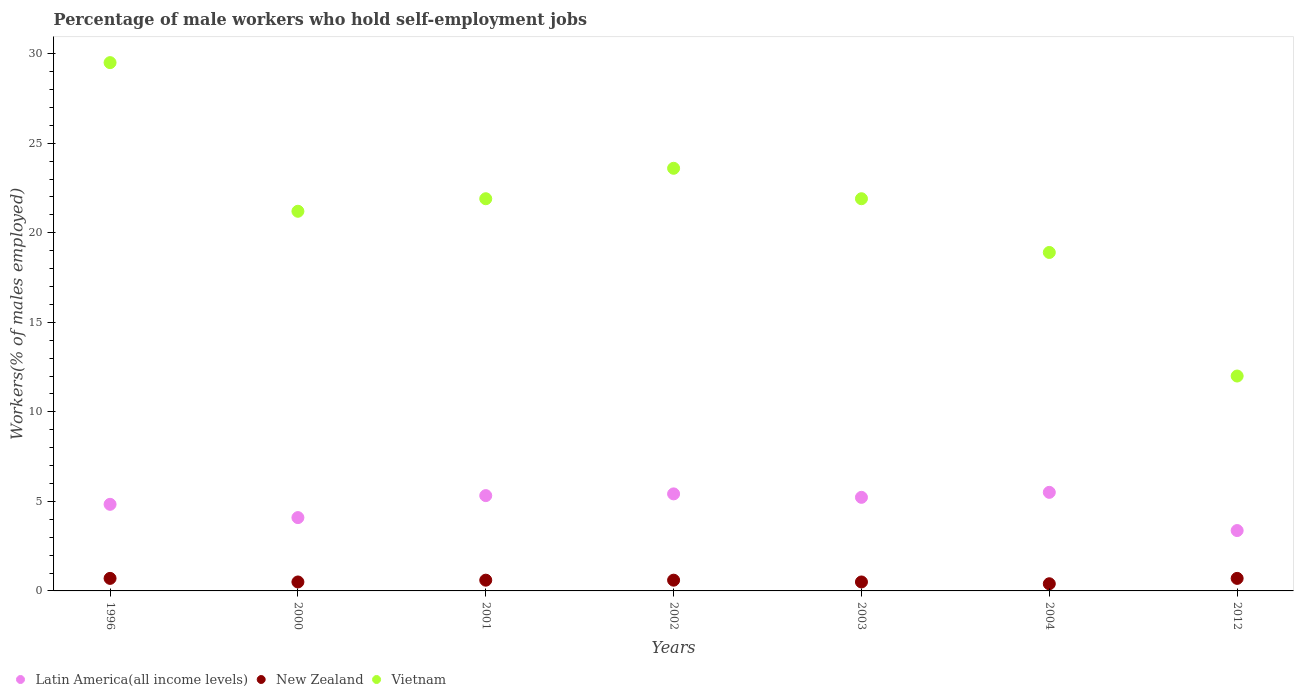How many different coloured dotlines are there?
Offer a terse response. 3. Is the number of dotlines equal to the number of legend labels?
Make the answer very short. Yes. What is the percentage of self-employed male workers in New Zealand in 2004?
Offer a very short reply. 0.4. Across all years, what is the maximum percentage of self-employed male workers in Latin America(all income levels)?
Offer a terse response. 5.5. Across all years, what is the minimum percentage of self-employed male workers in Vietnam?
Give a very brief answer. 12. In which year was the percentage of self-employed male workers in Latin America(all income levels) maximum?
Make the answer very short. 2004. In which year was the percentage of self-employed male workers in Latin America(all income levels) minimum?
Offer a terse response. 2012. What is the total percentage of self-employed male workers in New Zealand in the graph?
Your answer should be very brief. 4. What is the difference between the percentage of self-employed male workers in New Zealand in 2001 and that in 2003?
Your answer should be very brief. 0.1. What is the difference between the percentage of self-employed male workers in Latin America(all income levels) in 2002 and the percentage of self-employed male workers in Vietnam in 1996?
Offer a very short reply. -24.08. What is the average percentage of self-employed male workers in Vietnam per year?
Provide a succinct answer. 21.29. In the year 2003, what is the difference between the percentage of self-employed male workers in New Zealand and percentage of self-employed male workers in Vietnam?
Make the answer very short. -21.4. What is the ratio of the percentage of self-employed male workers in New Zealand in 2001 to that in 2003?
Provide a short and direct response. 1.2. Is the percentage of self-employed male workers in Vietnam in 2000 less than that in 2012?
Make the answer very short. No. Is the difference between the percentage of self-employed male workers in New Zealand in 2000 and 2003 greater than the difference between the percentage of self-employed male workers in Vietnam in 2000 and 2003?
Your answer should be very brief. Yes. What is the difference between the highest and the second highest percentage of self-employed male workers in Vietnam?
Make the answer very short. 5.9. What is the difference between the highest and the lowest percentage of self-employed male workers in Latin America(all income levels)?
Provide a succinct answer. 2.13. Is the sum of the percentage of self-employed male workers in New Zealand in 2002 and 2012 greater than the maximum percentage of self-employed male workers in Vietnam across all years?
Your answer should be very brief. No. Is it the case that in every year, the sum of the percentage of self-employed male workers in Latin America(all income levels) and percentage of self-employed male workers in New Zealand  is greater than the percentage of self-employed male workers in Vietnam?
Ensure brevity in your answer.  No. Is the percentage of self-employed male workers in Vietnam strictly less than the percentage of self-employed male workers in New Zealand over the years?
Give a very brief answer. No. How many dotlines are there?
Your answer should be compact. 3. How many years are there in the graph?
Your answer should be compact. 7. What is the difference between two consecutive major ticks on the Y-axis?
Offer a terse response. 5. Does the graph contain any zero values?
Offer a very short reply. No. Does the graph contain grids?
Provide a succinct answer. No. How many legend labels are there?
Offer a terse response. 3. How are the legend labels stacked?
Your response must be concise. Horizontal. What is the title of the graph?
Keep it short and to the point. Percentage of male workers who hold self-employment jobs. What is the label or title of the Y-axis?
Offer a very short reply. Workers(% of males employed). What is the Workers(% of males employed) of Latin America(all income levels) in 1996?
Keep it short and to the point. 4.84. What is the Workers(% of males employed) of New Zealand in 1996?
Keep it short and to the point. 0.7. What is the Workers(% of males employed) in Vietnam in 1996?
Offer a terse response. 29.5. What is the Workers(% of males employed) of Latin America(all income levels) in 2000?
Keep it short and to the point. 4.09. What is the Workers(% of males employed) of Vietnam in 2000?
Your response must be concise. 21.2. What is the Workers(% of males employed) of Latin America(all income levels) in 2001?
Make the answer very short. 5.32. What is the Workers(% of males employed) in New Zealand in 2001?
Give a very brief answer. 0.6. What is the Workers(% of males employed) of Vietnam in 2001?
Keep it short and to the point. 21.9. What is the Workers(% of males employed) of Latin America(all income levels) in 2002?
Your answer should be compact. 5.42. What is the Workers(% of males employed) of New Zealand in 2002?
Make the answer very short. 0.6. What is the Workers(% of males employed) in Vietnam in 2002?
Ensure brevity in your answer.  23.6. What is the Workers(% of males employed) in Latin America(all income levels) in 2003?
Your answer should be very brief. 5.23. What is the Workers(% of males employed) of New Zealand in 2003?
Your response must be concise. 0.5. What is the Workers(% of males employed) of Vietnam in 2003?
Offer a terse response. 21.9. What is the Workers(% of males employed) of Latin America(all income levels) in 2004?
Ensure brevity in your answer.  5.5. What is the Workers(% of males employed) in New Zealand in 2004?
Your response must be concise. 0.4. What is the Workers(% of males employed) in Vietnam in 2004?
Make the answer very short. 18.9. What is the Workers(% of males employed) in Latin America(all income levels) in 2012?
Provide a short and direct response. 3.37. What is the Workers(% of males employed) of New Zealand in 2012?
Provide a short and direct response. 0.7. Across all years, what is the maximum Workers(% of males employed) in Latin America(all income levels)?
Offer a very short reply. 5.5. Across all years, what is the maximum Workers(% of males employed) in New Zealand?
Keep it short and to the point. 0.7. Across all years, what is the maximum Workers(% of males employed) of Vietnam?
Your answer should be very brief. 29.5. Across all years, what is the minimum Workers(% of males employed) in Latin America(all income levels)?
Offer a terse response. 3.37. Across all years, what is the minimum Workers(% of males employed) in New Zealand?
Ensure brevity in your answer.  0.4. Across all years, what is the minimum Workers(% of males employed) in Vietnam?
Give a very brief answer. 12. What is the total Workers(% of males employed) in Latin America(all income levels) in the graph?
Provide a short and direct response. 33.77. What is the total Workers(% of males employed) of Vietnam in the graph?
Your answer should be very brief. 149. What is the difference between the Workers(% of males employed) of Latin America(all income levels) in 1996 and that in 2000?
Offer a terse response. 0.74. What is the difference between the Workers(% of males employed) of New Zealand in 1996 and that in 2000?
Ensure brevity in your answer.  0.2. What is the difference between the Workers(% of males employed) of Latin America(all income levels) in 1996 and that in 2001?
Your answer should be compact. -0.49. What is the difference between the Workers(% of males employed) of Vietnam in 1996 and that in 2001?
Offer a terse response. 7.6. What is the difference between the Workers(% of males employed) in Latin America(all income levels) in 1996 and that in 2002?
Your response must be concise. -0.58. What is the difference between the Workers(% of males employed) of New Zealand in 1996 and that in 2002?
Make the answer very short. 0.1. What is the difference between the Workers(% of males employed) of Vietnam in 1996 and that in 2002?
Give a very brief answer. 5.9. What is the difference between the Workers(% of males employed) of Latin America(all income levels) in 1996 and that in 2003?
Provide a short and direct response. -0.39. What is the difference between the Workers(% of males employed) in New Zealand in 1996 and that in 2003?
Your answer should be very brief. 0.2. What is the difference between the Workers(% of males employed) of Vietnam in 1996 and that in 2003?
Your answer should be very brief. 7.6. What is the difference between the Workers(% of males employed) of Latin America(all income levels) in 1996 and that in 2004?
Your answer should be compact. -0.67. What is the difference between the Workers(% of males employed) of New Zealand in 1996 and that in 2004?
Keep it short and to the point. 0.3. What is the difference between the Workers(% of males employed) in Latin America(all income levels) in 1996 and that in 2012?
Provide a succinct answer. 1.46. What is the difference between the Workers(% of males employed) of New Zealand in 1996 and that in 2012?
Make the answer very short. 0. What is the difference between the Workers(% of males employed) in Vietnam in 1996 and that in 2012?
Give a very brief answer. 17.5. What is the difference between the Workers(% of males employed) in Latin America(all income levels) in 2000 and that in 2001?
Make the answer very short. -1.23. What is the difference between the Workers(% of males employed) in New Zealand in 2000 and that in 2001?
Provide a short and direct response. -0.1. What is the difference between the Workers(% of males employed) in Latin America(all income levels) in 2000 and that in 2002?
Offer a very short reply. -1.32. What is the difference between the Workers(% of males employed) of New Zealand in 2000 and that in 2002?
Provide a short and direct response. -0.1. What is the difference between the Workers(% of males employed) in Vietnam in 2000 and that in 2002?
Offer a very short reply. -2.4. What is the difference between the Workers(% of males employed) in Latin America(all income levels) in 2000 and that in 2003?
Offer a terse response. -1.13. What is the difference between the Workers(% of males employed) of New Zealand in 2000 and that in 2003?
Keep it short and to the point. 0. What is the difference between the Workers(% of males employed) of Latin America(all income levels) in 2000 and that in 2004?
Provide a short and direct response. -1.41. What is the difference between the Workers(% of males employed) of New Zealand in 2000 and that in 2004?
Keep it short and to the point. 0.1. What is the difference between the Workers(% of males employed) in Vietnam in 2000 and that in 2004?
Provide a short and direct response. 2.3. What is the difference between the Workers(% of males employed) of Latin America(all income levels) in 2000 and that in 2012?
Ensure brevity in your answer.  0.72. What is the difference between the Workers(% of males employed) in Latin America(all income levels) in 2001 and that in 2002?
Your response must be concise. -0.1. What is the difference between the Workers(% of males employed) of New Zealand in 2001 and that in 2002?
Your response must be concise. 0. What is the difference between the Workers(% of males employed) of Vietnam in 2001 and that in 2002?
Keep it short and to the point. -1.7. What is the difference between the Workers(% of males employed) in Latin America(all income levels) in 2001 and that in 2003?
Provide a short and direct response. 0.1. What is the difference between the Workers(% of males employed) in New Zealand in 2001 and that in 2003?
Ensure brevity in your answer.  0.1. What is the difference between the Workers(% of males employed) in Vietnam in 2001 and that in 2003?
Provide a succinct answer. 0. What is the difference between the Workers(% of males employed) of Latin America(all income levels) in 2001 and that in 2004?
Provide a short and direct response. -0.18. What is the difference between the Workers(% of males employed) of Latin America(all income levels) in 2001 and that in 2012?
Offer a very short reply. 1.95. What is the difference between the Workers(% of males employed) of New Zealand in 2001 and that in 2012?
Offer a very short reply. -0.1. What is the difference between the Workers(% of males employed) of Latin America(all income levels) in 2002 and that in 2003?
Offer a very short reply. 0.19. What is the difference between the Workers(% of males employed) in Vietnam in 2002 and that in 2003?
Give a very brief answer. 1.7. What is the difference between the Workers(% of males employed) in Latin America(all income levels) in 2002 and that in 2004?
Your response must be concise. -0.09. What is the difference between the Workers(% of males employed) of Vietnam in 2002 and that in 2004?
Offer a terse response. 4.7. What is the difference between the Workers(% of males employed) of Latin America(all income levels) in 2002 and that in 2012?
Ensure brevity in your answer.  2.05. What is the difference between the Workers(% of males employed) of Vietnam in 2002 and that in 2012?
Offer a very short reply. 11.6. What is the difference between the Workers(% of males employed) of Latin America(all income levels) in 2003 and that in 2004?
Your answer should be very brief. -0.28. What is the difference between the Workers(% of males employed) of New Zealand in 2003 and that in 2004?
Offer a very short reply. 0.1. What is the difference between the Workers(% of males employed) in Vietnam in 2003 and that in 2004?
Ensure brevity in your answer.  3. What is the difference between the Workers(% of males employed) of Latin America(all income levels) in 2003 and that in 2012?
Ensure brevity in your answer.  1.85. What is the difference between the Workers(% of males employed) in Vietnam in 2003 and that in 2012?
Give a very brief answer. 9.9. What is the difference between the Workers(% of males employed) of Latin America(all income levels) in 2004 and that in 2012?
Provide a short and direct response. 2.13. What is the difference between the Workers(% of males employed) in New Zealand in 2004 and that in 2012?
Ensure brevity in your answer.  -0.3. What is the difference between the Workers(% of males employed) in Vietnam in 2004 and that in 2012?
Keep it short and to the point. 6.9. What is the difference between the Workers(% of males employed) in Latin America(all income levels) in 1996 and the Workers(% of males employed) in New Zealand in 2000?
Offer a terse response. 4.34. What is the difference between the Workers(% of males employed) of Latin America(all income levels) in 1996 and the Workers(% of males employed) of Vietnam in 2000?
Keep it short and to the point. -16.36. What is the difference between the Workers(% of males employed) of New Zealand in 1996 and the Workers(% of males employed) of Vietnam in 2000?
Provide a short and direct response. -20.5. What is the difference between the Workers(% of males employed) of Latin America(all income levels) in 1996 and the Workers(% of males employed) of New Zealand in 2001?
Make the answer very short. 4.24. What is the difference between the Workers(% of males employed) in Latin America(all income levels) in 1996 and the Workers(% of males employed) in Vietnam in 2001?
Your answer should be compact. -17.06. What is the difference between the Workers(% of males employed) of New Zealand in 1996 and the Workers(% of males employed) of Vietnam in 2001?
Offer a terse response. -21.2. What is the difference between the Workers(% of males employed) in Latin America(all income levels) in 1996 and the Workers(% of males employed) in New Zealand in 2002?
Give a very brief answer. 4.24. What is the difference between the Workers(% of males employed) in Latin America(all income levels) in 1996 and the Workers(% of males employed) in Vietnam in 2002?
Give a very brief answer. -18.76. What is the difference between the Workers(% of males employed) in New Zealand in 1996 and the Workers(% of males employed) in Vietnam in 2002?
Provide a short and direct response. -22.9. What is the difference between the Workers(% of males employed) of Latin America(all income levels) in 1996 and the Workers(% of males employed) of New Zealand in 2003?
Make the answer very short. 4.34. What is the difference between the Workers(% of males employed) of Latin America(all income levels) in 1996 and the Workers(% of males employed) of Vietnam in 2003?
Your response must be concise. -17.06. What is the difference between the Workers(% of males employed) of New Zealand in 1996 and the Workers(% of males employed) of Vietnam in 2003?
Your answer should be compact. -21.2. What is the difference between the Workers(% of males employed) in Latin America(all income levels) in 1996 and the Workers(% of males employed) in New Zealand in 2004?
Ensure brevity in your answer.  4.44. What is the difference between the Workers(% of males employed) of Latin America(all income levels) in 1996 and the Workers(% of males employed) of Vietnam in 2004?
Make the answer very short. -14.06. What is the difference between the Workers(% of males employed) of New Zealand in 1996 and the Workers(% of males employed) of Vietnam in 2004?
Provide a succinct answer. -18.2. What is the difference between the Workers(% of males employed) of Latin America(all income levels) in 1996 and the Workers(% of males employed) of New Zealand in 2012?
Offer a very short reply. 4.14. What is the difference between the Workers(% of males employed) in Latin America(all income levels) in 1996 and the Workers(% of males employed) in Vietnam in 2012?
Provide a succinct answer. -7.16. What is the difference between the Workers(% of males employed) of Latin America(all income levels) in 2000 and the Workers(% of males employed) of New Zealand in 2001?
Provide a short and direct response. 3.49. What is the difference between the Workers(% of males employed) in Latin America(all income levels) in 2000 and the Workers(% of males employed) in Vietnam in 2001?
Offer a terse response. -17.81. What is the difference between the Workers(% of males employed) of New Zealand in 2000 and the Workers(% of males employed) of Vietnam in 2001?
Provide a succinct answer. -21.4. What is the difference between the Workers(% of males employed) of Latin America(all income levels) in 2000 and the Workers(% of males employed) of New Zealand in 2002?
Provide a short and direct response. 3.49. What is the difference between the Workers(% of males employed) in Latin America(all income levels) in 2000 and the Workers(% of males employed) in Vietnam in 2002?
Offer a terse response. -19.51. What is the difference between the Workers(% of males employed) of New Zealand in 2000 and the Workers(% of males employed) of Vietnam in 2002?
Your answer should be compact. -23.1. What is the difference between the Workers(% of males employed) in Latin America(all income levels) in 2000 and the Workers(% of males employed) in New Zealand in 2003?
Offer a very short reply. 3.59. What is the difference between the Workers(% of males employed) of Latin America(all income levels) in 2000 and the Workers(% of males employed) of Vietnam in 2003?
Offer a terse response. -17.81. What is the difference between the Workers(% of males employed) of New Zealand in 2000 and the Workers(% of males employed) of Vietnam in 2003?
Ensure brevity in your answer.  -21.4. What is the difference between the Workers(% of males employed) in Latin America(all income levels) in 2000 and the Workers(% of males employed) in New Zealand in 2004?
Your answer should be very brief. 3.69. What is the difference between the Workers(% of males employed) of Latin America(all income levels) in 2000 and the Workers(% of males employed) of Vietnam in 2004?
Provide a short and direct response. -14.81. What is the difference between the Workers(% of males employed) in New Zealand in 2000 and the Workers(% of males employed) in Vietnam in 2004?
Make the answer very short. -18.4. What is the difference between the Workers(% of males employed) in Latin America(all income levels) in 2000 and the Workers(% of males employed) in New Zealand in 2012?
Your answer should be very brief. 3.39. What is the difference between the Workers(% of males employed) of Latin America(all income levels) in 2000 and the Workers(% of males employed) of Vietnam in 2012?
Your answer should be compact. -7.91. What is the difference between the Workers(% of males employed) of New Zealand in 2000 and the Workers(% of males employed) of Vietnam in 2012?
Your answer should be compact. -11.5. What is the difference between the Workers(% of males employed) of Latin America(all income levels) in 2001 and the Workers(% of males employed) of New Zealand in 2002?
Make the answer very short. 4.72. What is the difference between the Workers(% of males employed) of Latin America(all income levels) in 2001 and the Workers(% of males employed) of Vietnam in 2002?
Offer a very short reply. -18.28. What is the difference between the Workers(% of males employed) in New Zealand in 2001 and the Workers(% of males employed) in Vietnam in 2002?
Your answer should be compact. -23. What is the difference between the Workers(% of males employed) in Latin America(all income levels) in 2001 and the Workers(% of males employed) in New Zealand in 2003?
Offer a very short reply. 4.82. What is the difference between the Workers(% of males employed) of Latin America(all income levels) in 2001 and the Workers(% of males employed) of Vietnam in 2003?
Offer a terse response. -16.58. What is the difference between the Workers(% of males employed) in New Zealand in 2001 and the Workers(% of males employed) in Vietnam in 2003?
Your answer should be very brief. -21.3. What is the difference between the Workers(% of males employed) of Latin America(all income levels) in 2001 and the Workers(% of males employed) of New Zealand in 2004?
Give a very brief answer. 4.92. What is the difference between the Workers(% of males employed) of Latin America(all income levels) in 2001 and the Workers(% of males employed) of Vietnam in 2004?
Make the answer very short. -13.58. What is the difference between the Workers(% of males employed) in New Zealand in 2001 and the Workers(% of males employed) in Vietnam in 2004?
Your answer should be compact. -18.3. What is the difference between the Workers(% of males employed) in Latin America(all income levels) in 2001 and the Workers(% of males employed) in New Zealand in 2012?
Make the answer very short. 4.62. What is the difference between the Workers(% of males employed) of Latin America(all income levels) in 2001 and the Workers(% of males employed) of Vietnam in 2012?
Give a very brief answer. -6.68. What is the difference between the Workers(% of males employed) of Latin America(all income levels) in 2002 and the Workers(% of males employed) of New Zealand in 2003?
Your answer should be very brief. 4.92. What is the difference between the Workers(% of males employed) in Latin America(all income levels) in 2002 and the Workers(% of males employed) in Vietnam in 2003?
Your response must be concise. -16.48. What is the difference between the Workers(% of males employed) in New Zealand in 2002 and the Workers(% of males employed) in Vietnam in 2003?
Offer a very short reply. -21.3. What is the difference between the Workers(% of males employed) of Latin America(all income levels) in 2002 and the Workers(% of males employed) of New Zealand in 2004?
Offer a terse response. 5.02. What is the difference between the Workers(% of males employed) in Latin America(all income levels) in 2002 and the Workers(% of males employed) in Vietnam in 2004?
Give a very brief answer. -13.48. What is the difference between the Workers(% of males employed) in New Zealand in 2002 and the Workers(% of males employed) in Vietnam in 2004?
Offer a terse response. -18.3. What is the difference between the Workers(% of males employed) of Latin America(all income levels) in 2002 and the Workers(% of males employed) of New Zealand in 2012?
Your answer should be compact. 4.72. What is the difference between the Workers(% of males employed) of Latin America(all income levels) in 2002 and the Workers(% of males employed) of Vietnam in 2012?
Make the answer very short. -6.58. What is the difference between the Workers(% of males employed) in New Zealand in 2002 and the Workers(% of males employed) in Vietnam in 2012?
Your answer should be compact. -11.4. What is the difference between the Workers(% of males employed) of Latin America(all income levels) in 2003 and the Workers(% of males employed) of New Zealand in 2004?
Your answer should be very brief. 4.83. What is the difference between the Workers(% of males employed) of Latin America(all income levels) in 2003 and the Workers(% of males employed) of Vietnam in 2004?
Your answer should be very brief. -13.67. What is the difference between the Workers(% of males employed) in New Zealand in 2003 and the Workers(% of males employed) in Vietnam in 2004?
Offer a terse response. -18.4. What is the difference between the Workers(% of males employed) in Latin America(all income levels) in 2003 and the Workers(% of males employed) in New Zealand in 2012?
Keep it short and to the point. 4.53. What is the difference between the Workers(% of males employed) in Latin America(all income levels) in 2003 and the Workers(% of males employed) in Vietnam in 2012?
Ensure brevity in your answer.  -6.77. What is the difference between the Workers(% of males employed) of Latin America(all income levels) in 2004 and the Workers(% of males employed) of New Zealand in 2012?
Your answer should be very brief. 4.8. What is the difference between the Workers(% of males employed) of Latin America(all income levels) in 2004 and the Workers(% of males employed) of Vietnam in 2012?
Offer a very short reply. -6.5. What is the difference between the Workers(% of males employed) of New Zealand in 2004 and the Workers(% of males employed) of Vietnam in 2012?
Ensure brevity in your answer.  -11.6. What is the average Workers(% of males employed) of Latin America(all income levels) per year?
Your answer should be compact. 4.82. What is the average Workers(% of males employed) in Vietnam per year?
Ensure brevity in your answer.  21.29. In the year 1996, what is the difference between the Workers(% of males employed) of Latin America(all income levels) and Workers(% of males employed) of New Zealand?
Make the answer very short. 4.14. In the year 1996, what is the difference between the Workers(% of males employed) of Latin America(all income levels) and Workers(% of males employed) of Vietnam?
Your answer should be compact. -24.66. In the year 1996, what is the difference between the Workers(% of males employed) in New Zealand and Workers(% of males employed) in Vietnam?
Make the answer very short. -28.8. In the year 2000, what is the difference between the Workers(% of males employed) of Latin America(all income levels) and Workers(% of males employed) of New Zealand?
Offer a terse response. 3.59. In the year 2000, what is the difference between the Workers(% of males employed) in Latin America(all income levels) and Workers(% of males employed) in Vietnam?
Your answer should be very brief. -17.11. In the year 2000, what is the difference between the Workers(% of males employed) of New Zealand and Workers(% of males employed) of Vietnam?
Make the answer very short. -20.7. In the year 2001, what is the difference between the Workers(% of males employed) in Latin America(all income levels) and Workers(% of males employed) in New Zealand?
Offer a very short reply. 4.72. In the year 2001, what is the difference between the Workers(% of males employed) in Latin America(all income levels) and Workers(% of males employed) in Vietnam?
Ensure brevity in your answer.  -16.58. In the year 2001, what is the difference between the Workers(% of males employed) of New Zealand and Workers(% of males employed) of Vietnam?
Your answer should be very brief. -21.3. In the year 2002, what is the difference between the Workers(% of males employed) of Latin America(all income levels) and Workers(% of males employed) of New Zealand?
Ensure brevity in your answer.  4.82. In the year 2002, what is the difference between the Workers(% of males employed) in Latin America(all income levels) and Workers(% of males employed) in Vietnam?
Provide a succinct answer. -18.18. In the year 2003, what is the difference between the Workers(% of males employed) in Latin America(all income levels) and Workers(% of males employed) in New Zealand?
Provide a short and direct response. 4.73. In the year 2003, what is the difference between the Workers(% of males employed) in Latin America(all income levels) and Workers(% of males employed) in Vietnam?
Make the answer very short. -16.67. In the year 2003, what is the difference between the Workers(% of males employed) of New Zealand and Workers(% of males employed) of Vietnam?
Ensure brevity in your answer.  -21.4. In the year 2004, what is the difference between the Workers(% of males employed) of Latin America(all income levels) and Workers(% of males employed) of New Zealand?
Your answer should be very brief. 5.1. In the year 2004, what is the difference between the Workers(% of males employed) of Latin America(all income levels) and Workers(% of males employed) of Vietnam?
Ensure brevity in your answer.  -13.4. In the year 2004, what is the difference between the Workers(% of males employed) of New Zealand and Workers(% of males employed) of Vietnam?
Provide a succinct answer. -18.5. In the year 2012, what is the difference between the Workers(% of males employed) of Latin America(all income levels) and Workers(% of males employed) of New Zealand?
Provide a short and direct response. 2.67. In the year 2012, what is the difference between the Workers(% of males employed) of Latin America(all income levels) and Workers(% of males employed) of Vietnam?
Offer a very short reply. -8.63. In the year 2012, what is the difference between the Workers(% of males employed) of New Zealand and Workers(% of males employed) of Vietnam?
Offer a terse response. -11.3. What is the ratio of the Workers(% of males employed) in Latin America(all income levels) in 1996 to that in 2000?
Your response must be concise. 1.18. What is the ratio of the Workers(% of males employed) of New Zealand in 1996 to that in 2000?
Keep it short and to the point. 1.4. What is the ratio of the Workers(% of males employed) in Vietnam in 1996 to that in 2000?
Your answer should be very brief. 1.39. What is the ratio of the Workers(% of males employed) in Latin America(all income levels) in 1996 to that in 2001?
Provide a short and direct response. 0.91. What is the ratio of the Workers(% of males employed) of Vietnam in 1996 to that in 2001?
Make the answer very short. 1.35. What is the ratio of the Workers(% of males employed) in Latin America(all income levels) in 1996 to that in 2002?
Your response must be concise. 0.89. What is the ratio of the Workers(% of males employed) in New Zealand in 1996 to that in 2002?
Make the answer very short. 1.17. What is the ratio of the Workers(% of males employed) of Latin America(all income levels) in 1996 to that in 2003?
Provide a succinct answer. 0.93. What is the ratio of the Workers(% of males employed) of New Zealand in 1996 to that in 2003?
Keep it short and to the point. 1.4. What is the ratio of the Workers(% of males employed) in Vietnam in 1996 to that in 2003?
Keep it short and to the point. 1.35. What is the ratio of the Workers(% of males employed) in Latin America(all income levels) in 1996 to that in 2004?
Ensure brevity in your answer.  0.88. What is the ratio of the Workers(% of males employed) of Vietnam in 1996 to that in 2004?
Offer a terse response. 1.56. What is the ratio of the Workers(% of males employed) in Latin America(all income levels) in 1996 to that in 2012?
Keep it short and to the point. 1.43. What is the ratio of the Workers(% of males employed) in New Zealand in 1996 to that in 2012?
Give a very brief answer. 1. What is the ratio of the Workers(% of males employed) in Vietnam in 1996 to that in 2012?
Your answer should be compact. 2.46. What is the ratio of the Workers(% of males employed) of Latin America(all income levels) in 2000 to that in 2001?
Give a very brief answer. 0.77. What is the ratio of the Workers(% of males employed) of New Zealand in 2000 to that in 2001?
Your answer should be compact. 0.83. What is the ratio of the Workers(% of males employed) in Latin America(all income levels) in 2000 to that in 2002?
Give a very brief answer. 0.76. What is the ratio of the Workers(% of males employed) in New Zealand in 2000 to that in 2002?
Ensure brevity in your answer.  0.83. What is the ratio of the Workers(% of males employed) of Vietnam in 2000 to that in 2002?
Offer a very short reply. 0.9. What is the ratio of the Workers(% of males employed) in Latin America(all income levels) in 2000 to that in 2003?
Make the answer very short. 0.78. What is the ratio of the Workers(% of males employed) of Latin America(all income levels) in 2000 to that in 2004?
Provide a short and direct response. 0.74. What is the ratio of the Workers(% of males employed) of New Zealand in 2000 to that in 2004?
Give a very brief answer. 1.25. What is the ratio of the Workers(% of males employed) in Vietnam in 2000 to that in 2004?
Provide a short and direct response. 1.12. What is the ratio of the Workers(% of males employed) in Latin America(all income levels) in 2000 to that in 2012?
Provide a short and direct response. 1.21. What is the ratio of the Workers(% of males employed) of Vietnam in 2000 to that in 2012?
Make the answer very short. 1.77. What is the ratio of the Workers(% of males employed) of Latin America(all income levels) in 2001 to that in 2002?
Make the answer very short. 0.98. What is the ratio of the Workers(% of males employed) of New Zealand in 2001 to that in 2002?
Your answer should be very brief. 1. What is the ratio of the Workers(% of males employed) of Vietnam in 2001 to that in 2002?
Your answer should be very brief. 0.93. What is the ratio of the Workers(% of males employed) of Latin America(all income levels) in 2001 to that in 2003?
Your response must be concise. 1.02. What is the ratio of the Workers(% of males employed) of Latin America(all income levels) in 2001 to that in 2004?
Your response must be concise. 0.97. What is the ratio of the Workers(% of males employed) of Vietnam in 2001 to that in 2004?
Offer a terse response. 1.16. What is the ratio of the Workers(% of males employed) of Latin America(all income levels) in 2001 to that in 2012?
Your answer should be compact. 1.58. What is the ratio of the Workers(% of males employed) of Vietnam in 2001 to that in 2012?
Your answer should be very brief. 1.82. What is the ratio of the Workers(% of males employed) in Latin America(all income levels) in 2002 to that in 2003?
Provide a succinct answer. 1.04. What is the ratio of the Workers(% of males employed) in Vietnam in 2002 to that in 2003?
Offer a terse response. 1.08. What is the ratio of the Workers(% of males employed) of Latin America(all income levels) in 2002 to that in 2004?
Give a very brief answer. 0.98. What is the ratio of the Workers(% of males employed) in Vietnam in 2002 to that in 2004?
Offer a very short reply. 1.25. What is the ratio of the Workers(% of males employed) of Latin America(all income levels) in 2002 to that in 2012?
Ensure brevity in your answer.  1.61. What is the ratio of the Workers(% of males employed) in Vietnam in 2002 to that in 2012?
Provide a succinct answer. 1.97. What is the ratio of the Workers(% of males employed) in Latin America(all income levels) in 2003 to that in 2004?
Your response must be concise. 0.95. What is the ratio of the Workers(% of males employed) in New Zealand in 2003 to that in 2004?
Your answer should be compact. 1.25. What is the ratio of the Workers(% of males employed) of Vietnam in 2003 to that in 2004?
Ensure brevity in your answer.  1.16. What is the ratio of the Workers(% of males employed) in Latin America(all income levels) in 2003 to that in 2012?
Offer a very short reply. 1.55. What is the ratio of the Workers(% of males employed) in Vietnam in 2003 to that in 2012?
Your response must be concise. 1.82. What is the ratio of the Workers(% of males employed) of Latin America(all income levels) in 2004 to that in 2012?
Make the answer very short. 1.63. What is the ratio of the Workers(% of males employed) of Vietnam in 2004 to that in 2012?
Offer a terse response. 1.57. What is the difference between the highest and the second highest Workers(% of males employed) in Latin America(all income levels)?
Offer a terse response. 0.09. What is the difference between the highest and the lowest Workers(% of males employed) of Latin America(all income levels)?
Your answer should be compact. 2.13. What is the difference between the highest and the lowest Workers(% of males employed) of Vietnam?
Offer a very short reply. 17.5. 